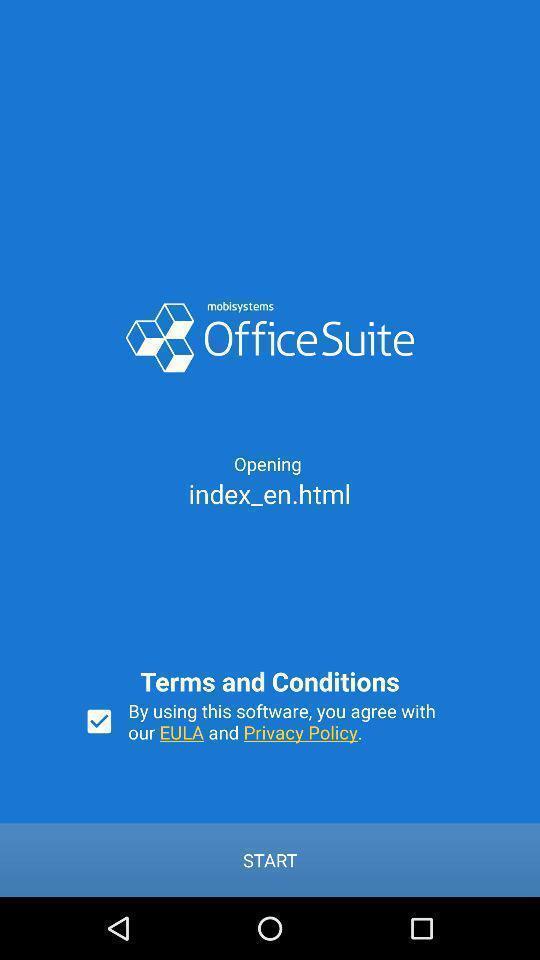Please provide a description for this image. Welcome page to accept terms and conditions. 